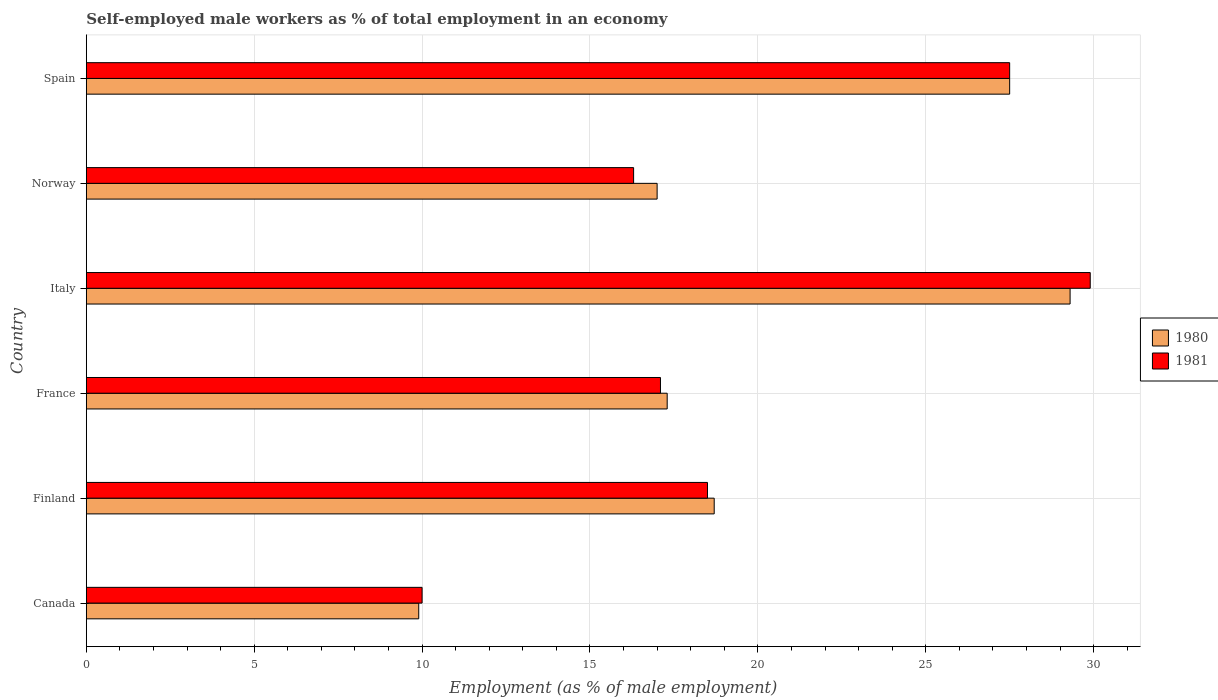In how many cases, is the number of bars for a given country not equal to the number of legend labels?
Offer a terse response. 0. What is the percentage of self-employed male workers in 1981 in Norway?
Offer a very short reply. 16.3. Across all countries, what is the maximum percentage of self-employed male workers in 1980?
Provide a short and direct response. 29.3. Across all countries, what is the minimum percentage of self-employed male workers in 1980?
Ensure brevity in your answer.  9.9. What is the total percentage of self-employed male workers in 1980 in the graph?
Give a very brief answer. 119.7. What is the difference between the percentage of self-employed male workers in 1981 in Finland and that in France?
Your response must be concise. 1.4. What is the difference between the percentage of self-employed male workers in 1980 in Finland and the percentage of self-employed male workers in 1981 in Spain?
Keep it short and to the point. -8.8. What is the average percentage of self-employed male workers in 1980 per country?
Give a very brief answer. 19.95. What is the difference between the percentage of self-employed male workers in 1981 and percentage of self-employed male workers in 1980 in Spain?
Provide a succinct answer. 0. In how many countries, is the percentage of self-employed male workers in 1980 greater than 29 %?
Your answer should be very brief. 1. What is the ratio of the percentage of self-employed male workers in 1981 in Finland to that in France?
Offer a terse response. 1.08. Is the difference between the percentage of self-employed male workers in 1981 in Canada and Italy greater than the difference between the percentage of self-employed male workers in 1980 in Canada and Italy?
Give a very brief answer. No. What is the difference between the highest and the second highest percentage of self-employed male workers in 1980?
Provide a succinct answer. 1.8. What is the difference between the highest and the lowest percentage of self-employed male workers in 1981?
Your response must be concise. 19.9. Is the sum of the percentage of self-employed male workers in 1980 in Finland and France greater than the maximum percentage of self-employed male workers in 1981 across all countries?
Your answer should be very brief. Yes. What is the difference between two consecutive major ticks on the X-axis?
Make the answer very short. 5. Are the values on the major ticks of X-axis written in scientific E-notation?
Your answer should be compact. No. How are the legend labels stacked?
Offer a terse response. Vertical. What is the title of the graph?
Give a very brief answer. Self-employed male workers as % of total employment in an economy. What is the label or title of the X-axis?
Your answer should be compact. Employment (as % of male employment). What is the Employment (as % of male employment) in 1980 in Canada?
Ensure brevity in your answer.  9.9. What is the Employment (as % of male employment) in 1980 in Finland?
Give a very brief answer. 18.7. What is the Employment (as % of male employment) in 1980 in France?
Provide a succinct answer. 17.3. What is the Employment (as % of male employment) of 1981 in France?
Offer a terse response. 17.1. What is the Employment (as % of male employment) in 1980 in Italy?
Keep it short and to the point. 29.3. What is the Employment (as % of male employment) in 1981 in Italy?
Your response must be concise. 29.9. What is the Employment (as % of male employment) in 1980 in Norway?
Provide a short and direct response. 17. What is the Employment (as % of male employment) in 1981 in Norway?
Provide a succinct answer. 16.3. What is the Employment (as % of male employment) of 1980 in Spain?
Offer a very short reply. 27.5. Across all countries, what is the maximum Employment (as % of male employment) in 1980?
Provide a short and direct response. 29.3. Across all countries, what is the maximum Employment (as % of male employment) in 1981?
Offer a terse response. 29.9. Across all countries, what is the minimum Employment (as % of male employment) of 1980?
Your response must be concise. 9.9. Across all countries, what is the minimum Employment (as % of male employment) in 1981?
Your response must be concise. 10. What is the total Employment (as % of male employment) in 1980 in the graph?
Your answer should be compact. 119.7. What is the total Employment (as % of male employment) of 1981 in the graph?
Offer a terse response. 119.3. What is the difference between the Employment (as % of male employment) in 1980 in Canada and that in Finland?
Provide a succinct answer. -8.8. What is the difference between the Employment (as % of male employment) in 1981 in Canada and that in Finland?
Make the answer very short. -8.5. What is the difference between the Employment (as % of male employment) in 1980 in Canada and that in France?
Give a very brief answer. -7.4. What is the difference between the Employment (as % of male employment) in 1981 in Canada and that in France?
Ensure brevity in your answer.  -7.1. What is the difference between the Employment (as % of male employment) in 1980 in Canada and that in Italy?
Offer a terse response. -19.4. What is the difference between the Employment (as % of male employment) in 1981 in Canada and that in Italy?
Your answer should be very brief. -19.9. What is the difference between the Employment (as % of male employment) of 1980 in Canada and that in Norway?
Keep it short and to the point. -7.1. What is the difference between the Employment (as % of male employment) in 1981 in Canada and that in Norway?
Provide a short and direct response. -6.3. What is the difference between the Employment (as % of male employment) in 1980 in Canada and that in Spain?
Offer a terse response. -17.6. What is the difference between the Employment (as % of male employment) of 1981 in Canada and that in Spain?
Your answer should be compact. -17.5. What is the difference between the Employment (as % of male employment) of 1980 in Finland and that in France?
Offer a terse response. 1.4. What is the difference between the Employment (as % of male employment) in 1980 in Finland and that in Italy?
Provide a short and direct response. -10.6. What is the difference between the Employment (as % of male employment) in 1981 in Finland and that in Italy?
Your answer should be very brief. -11.4. What is the difference between the Employment (as % of male employment) of 1980 in France and that in Norway?
Offer a terse response. 0.3. What is the difference between the Employment (as % of male employment) in 1981 in France and that in Norway?
Your answer should be very brief. 0.8. What is the difference between the Employment (as % of male employment) of 1980 in France and that in Spain?
Ensure brevity in your answer.  -10.2. What is the difference between the Employment (as % of male employment) in 1981 in France and that in Spain?
Provide a succinct answer. -10.4. What is the difference between the Employment (as % of male employment) of 1980 in Italy and that in Norway?
Ensure brevity in your answer.  12.3. What is the difference between the Employment (as % of male employment) in 1980 in Italy and that in Spain?
Offer a very short reply. 1.8. What is the difference between the Employment (as % of male employment) of 1980 in Canada and the Employment (as % of male employment) of 1981 in Norway?
Ensure brevity in your answer.  -6.4. What is the difference between the Employment (as % of male employment) of 1980 in Canada and the Employment (as % of male employment) of 1981 in Spain?
Make the answer very short. -17.6. What is the difference between the Employment (as % of male employment) of 1980 in Finland and the Employment (as % of male employment) of 1981 in France?
Make the answer very short. 1.6. What is the difference between the Employment (as % of male employment) in 1980 in Finland and the Employment (as % of male employment) in 1981 in Italy?
Give a very brief answer. -11.2. What is the difference between the Employment (as % of male employment) of 1980 in Finland and the Employment (as % of male employment) of 1981 in Spain?
Your response must be concise. -8.8. What is the difference between the Employment (as % of male employment) in 1980 in France and the Employment (as % of male employment) in 1981 in Italy?
Offer a very short reply. -12.6. What is the difference between the Employment (as % of male employment) of 1980 in France and the Employment (as % of male employment) of 1981 in Norway?
Keep it short and to the point. 1. What is the difference between the Employment (as % of male employment) in 1980 in Italy and the Employment (as % of male employment) in 1981 in Norway?
Your answer should be very brief. 13. What is the difference between the Employment (as % of male employment) in 1980 in Norway and the Employment (as % of male employment) in 1981 in Spain?
Offer a terse response. -10.5. What is the average Employment (as % of male employment) in 1980 per country?
Offer a terse response. 19.95. What is the average Employment (as % of male employment) in 1981 per country?
Keep it short and to the point. 19.88. What is the difference between the Employment (as % of male employment) of 1980 and Employment (as % of male employment) of 1981 in France?
Make the answer very short. 0.2. What is the difference between the Employment (as % of male employment) of 1980 and Employment (as % of male employment) of 1981 in Norway?
Provide a short and direct response. 0.7. What is the difference between the Employment (as % of male employment) of 1980 and Employment (as % of male employment) of 1981 in Spain?
Your answer should be compact. 0. What is the ratio of the Employment (as % of male employment) in 1980 in Canada to that in Finland?
Offer a very short reply. 0.53. What is the ratio of the Employment (as % of male employment) of 1981 in Canada to that in Finland?
Provide a succinct answer. 0.54. What is the ratio of the Employment (as % of male employment) in 1980 in Canada to that in France?
Your response must be concise. 0.57. What is the ratio of the Employment (as % of male employment) of 1981 in Canada to that in France?
Your response must be concise. 0.58. What is the ratio of the Employment (as % of male employment) of 1980 in Canada to that in Italy?
Offer a terse response. 0.34. What is the ratio of the Employment (as % of male employment) of 1981 in Canada to that in Italy?
Offer a terse response. 0.33. What is the ratio of the Employment (as % of male employment) in 1980 in Canada to that in Norway?
Provide a succinct answer. 0.58. What is the ratio of the Employment (as % of male employment) in 1981 in Canada to that in Norway?
Your answer should be very brief. 0.61. What is the ratio of the Employment (as % of male employment) of 1980 in Canada to that in Spain?
Ensure brevity in your answer.  0.36. What is the ratio of the Employment (as % of male employment) of 1981 in Canada to that in Spain?
Provide a succinct answer. 0.36. What is the ratio of the Employment (as % of male employment) in 1980 in Finland to that in France?
Make the answer very short. 1.08. What is the ratio of the Employment (as % of male employment) of 1981 in Finland to that in France?
Provide a short and direct response. 1.08. What is the ratio of the Employment (as % of male employment) of 1980 in Finland to that in Italy?
Your answer should be very brief. 0.64. What is the ratio of the Employment (as % of male employment) in 1981 in Finland to that in Italy?
Ensure brevity in your answer.  0.62. What is the ratio of the Employment (as % of male employment) of 1981 in Finland to that in Norway?
Ensure brevity in your answer.  1.14. What is the ratio of the Employment (as % of male employment) in 1980 in Finland to that in Spain?
Your answer should be very brief. 0.68. What is the ratio of the Employment (as % of male employment) in 1981 in Finland to that in Spain?
Offer a terse response. 0.67. What is the ratio of the Employment (as % of male employment) in 1980 in France to that in Italy?
Offer a terse response. 0.59. What is the ratio of the Employment (as % of male employment) in 1981 in France to that in Italy?
Give a very brief answer. 0.57. What is the ratio of the Employment (as % of male employment) of 1980 in France to that in Norway?
Your answer should be very brief. 1.02. What is the ratio of the Employment (as % of male employment) in 1981 in France to that in Norway?
Give a very brief answer. 1.05. What is the ratio of the Employment (as % of male employment) in 1980 in France to that in Spain?
Ensure brevity in your answer.  0.63. What is the ratio of the Employment (as % of male employment) of 1981 in France to that in Spain?
Keep it short and to the point. 0.62. What is the ratio of the Employment (as % of male employment) of 1980 in Italy to that in Norway?
Make the answer very short. 1.72. What is the ratio of the Employment (as % of male employment) in 1981 in Italy to that in Norway?
Your answer should be compact. 1.83. What is the ratio of the Employment (as % of male employment) of 1980 in Italy to that in Spain?
Offer a very short reply. 1.07. What is the ratio of the Employment (as % of male employment) of 1981 in Italy to that in Spain?
Your answer should be compact. 1.09. What is the ratio of the Employment (as % of male employment) of 1980 in Norway to that in Spain?
Make the answer very short. 0.62. What is the ratio of the Employment (as % of male employment) in 1981 in Norway to that in Spain?
Ensure brevity in your answer.  0.59. 